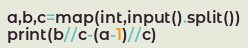Convert code to text. <code><loc_0><loc_0><loc_500><loc_500><_Python_>a,b,c=map(int,input().split())
print(b//c-(a-1)//c)</code> 